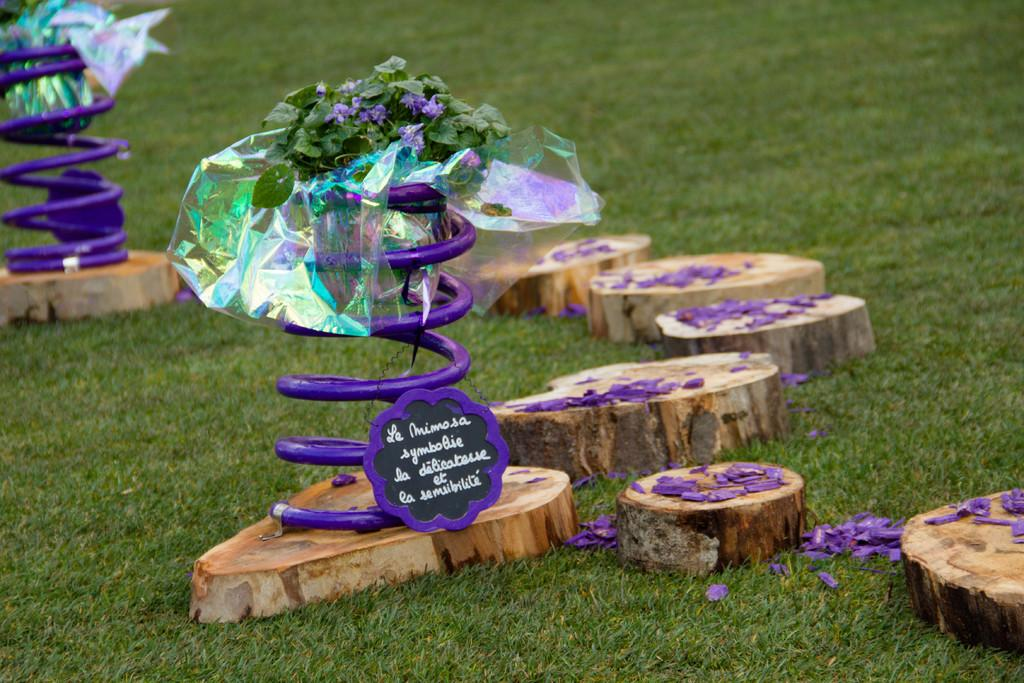What can be seen in the image that suggests a celebration or festive event? There are decorations and party confetti present in the image. Where are the decorations and confetti located in the image? The decorations and confetti are placed on the ground. What type of pump is being used to inflate the decorations in the image? There is no pump present in the image, and the decorations do not appear to be inflatable. 